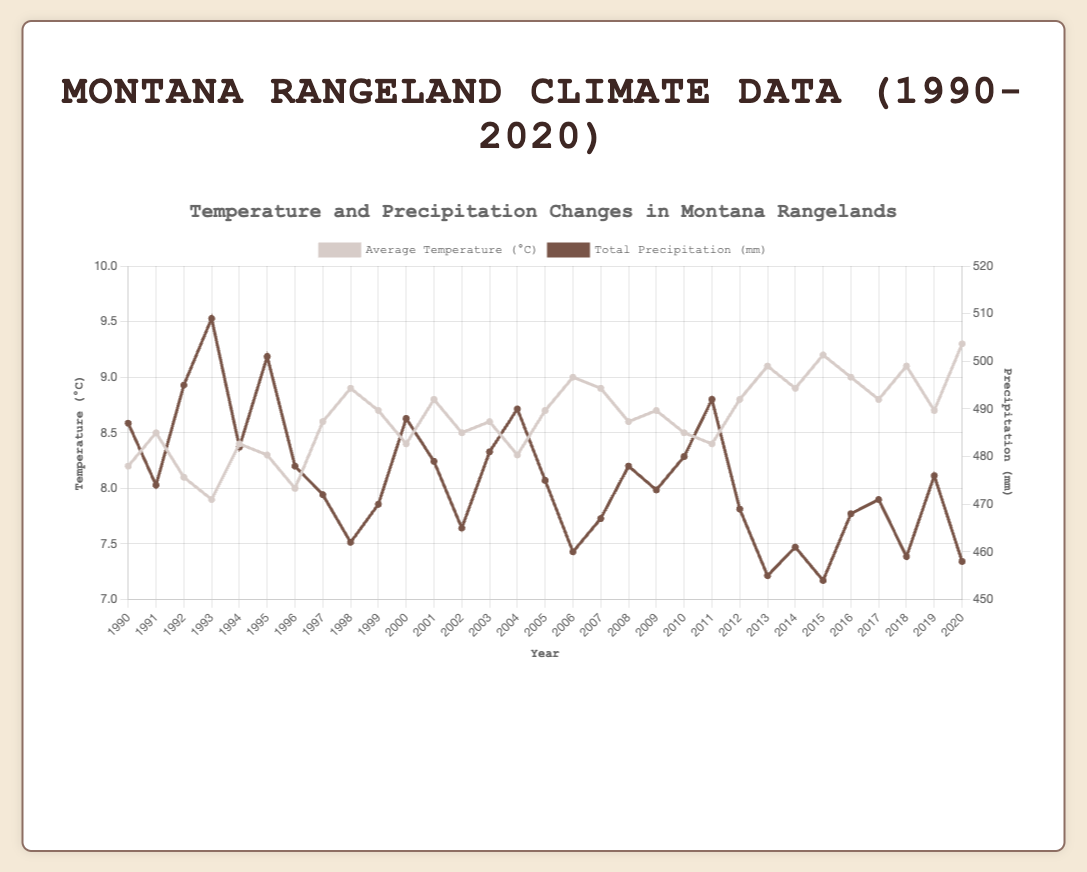What's the average temperature over the entire period? To find the average temperature over 1990 to 2020, sum all the yearly average temperatures and divide by the total number of years (31). The sum is \( (8.2 + 8.5 + 8.1 + 7.9 + 8.4 + 8.3 + 8.0 + 8.6 + 8.9 + 8.7 + 8.4 + 8.8 + 8.5 + 8.6 + 8.3 + 8.7 + 9.0 + 8.9 + 8.6 + 8.7 + 8.5 + 8.4 + 8.8 + 9.1 + 8.9 + 9.2 + 9.0 + 8.8 + 9.1 + 8.7 + 9.3) = 267.3 \), and the average is \( 267.3 / 31 = 8.624 \) °C
Answer: 8.6 °C Which year recorded the highest precipitation? Look at the total precipitation data for each year and identify the highest value. The year 1993 has the highest precipitation with 509 mm.
Answer: 1993 What was the temperature difference between the highest and lowest years? Identify the years with the highest (2020, 9.3°C) and lowest (1993, 7.9°C) average temperatures, then subtract the lowest from the highest. \( 9.3 - 7.9 = 1.4 \) °C
Answer: 1.4 °C How did the average temperature in 2003 compare to the precipitation in the same year? Note the average temperature (8.6°C) and total precipitation (481 mm) in 2003. This is a straightforward observation from the figure.
Answer: 8.6°C vs 481 mm Did any years have exactly equal average temperatures? Scan through the temperatures to find matching values. The years 1995 and 2004 both had an average temperature of 8.3°C.
Answer: 1995 and 2004 What's the total precipitation over the period from 2000 to 2009? Sum the yearly precipitation from 2000 to 2009. \( 488 + 479 + 465 + 481 + 490 + 475 + 460 + 467 + 478 + 473 = 4556 \) mm
Answer: 4556 mm Which trended more consistently upwards: temperature or precipitation? Compare the general trend of the lines representing temperature and precipitation. The temperature shows a more consistent upward trend compared to precipitation, which fluctuates more.
Answer: Temperature What was the average yearly precipitation in the 1990s? Sum the precipitation data from 1990 to 1999 and divide by 10. Sum is \( 487 + 474 + 495 + 509 + 482 + 501 + 478 + 472 + 462 + 470 = 4730 \). The average is \( 4730 / 10 = 473 \) mm
Answer: 473 mm Did any year have a temperature greater than or equal to 9°C and precipitation less than 460 mm? Check years with an average temperature ≥ 9°C. Years: 2006 (9°C, 460mm), 2013 (9.1°C, 455mm), 2015 (9.2°C, 454mm), 2018 (9.1°C, 459mm), 2020 (9.3°C, 458mm). Only 2013 and 2015 had precipitation less than 460 mm.
Answer: 2013 and 2015 Is there any year where both temperature and precipitation decreased compared to the previous year? Inspect each year's data relative to the previous year's values. For example, between 1991 and 1990, temperature increased from 8.2°C to 8.5°C while precipitation decreased. Repeat for other years. 1998 had both values lower than 1997 (temp 8.9°C to 8.6°C; precip 462 mm to 472 mm).
Answer: 1998 